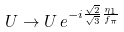<formula> <loc_0><loc_0><loc_500><loc_500>U \rightarrow U \, e ^ { - i { \frac { \sqrt { 2 } } { \sqrt { 3 } } } { \frac { \eta _ { 1 } } { f _ { \pi } } } }</formula> 